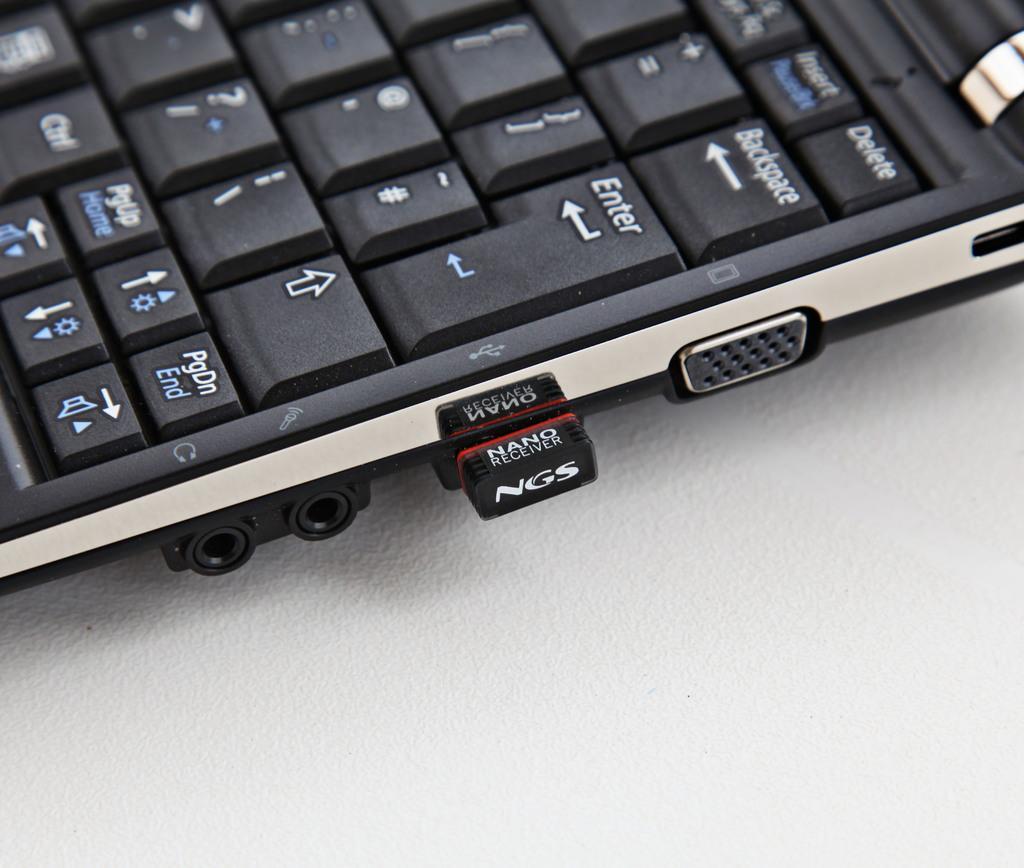Can you describe this image briefly? In the foreground of this image, there is a keyboard of a laptop and few ports and also a receiver connected to it. 